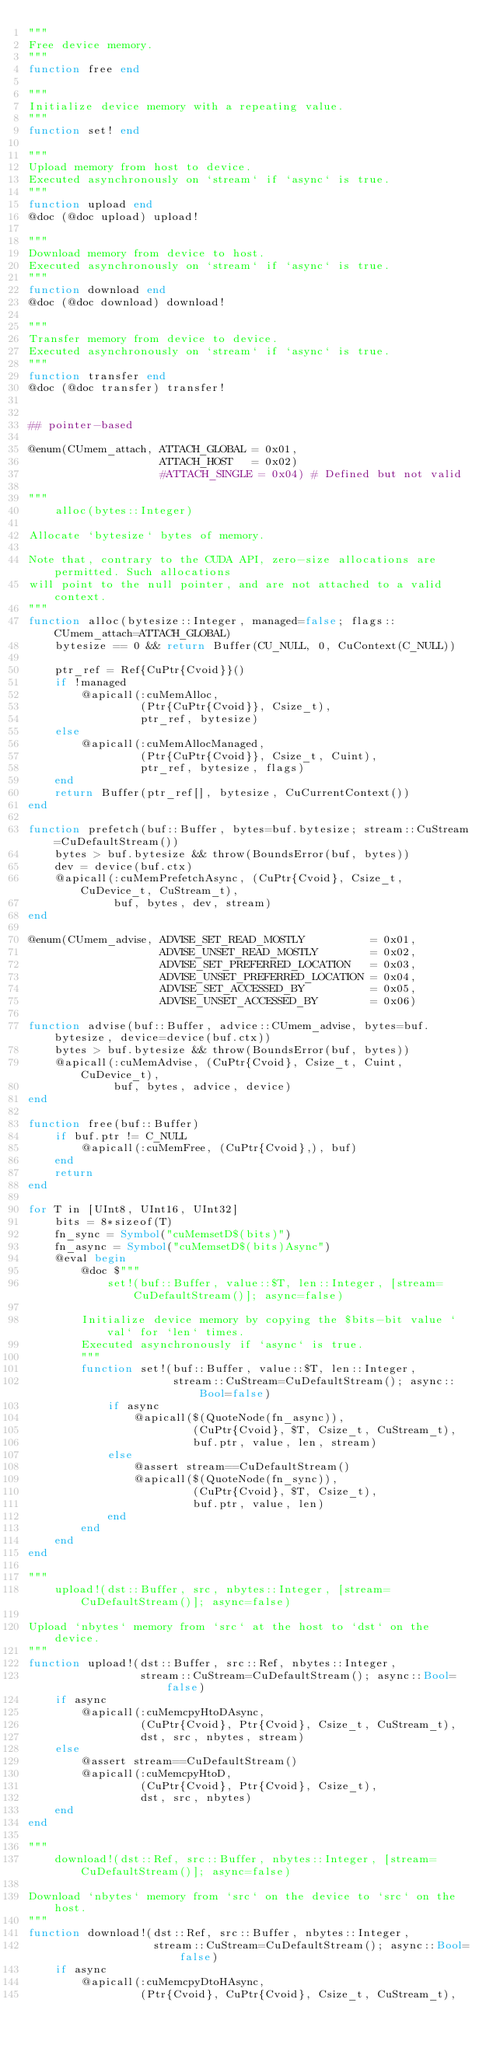<code> <loc_0><loc_0><loc_500><loc_500><_Julia_>"""
Free device memory.
"""
function free end

"""
Initialize device memory with a repeating value.
"""
function set! end

"""
Upload memory from host to device.
Executed asynchronously on `stream` if `async` is true.
"""
function upload end
@doc (@doc upload) upload!

"""
Download memory from device to host.
Executed asynchronously on `stream` if `async` is true.
"""
function download end
@doc (@doc download) download!

"""
Transfer memory from device to device.
Executed asynchronously on `stream` if `async` is true.
"""
function transfer end
@doc (@doc transfer) transfer!


## pointer-based

@enum(CUmem_attach, ATTACH_GLOBAL = 0x01,
                    ATTACH_HOST   = 0x02)
                    #ATTACH_SINGLE = 0x04) # Defined but not valid

"""
    alloc(bytes::Integer)

Allocate `bytesize` bytes of memory.

Note that, contrary to the CUDA API, zero-size allocations are permitted. Such allocations
will point to the null pointer, and are not attached to a valid context.
"""
function alloc(bytesize::Integer, managed=false; flags::CUmem_attach=ATTACH_GLOBAL)
    bytesize == 0 && return Buffer(CU_NULL, 0, CuContext(C_NULL))

    ptr_ref = Ref{CuPtr{Cvoid}}()
    if !managed
        @apicall(:cuMemAlloc,
                 (Ptr{CuPtr{Cvoid}}, Csize_t),
                 ptr_ref, bytesize)
    else
        @apicall(:cuMemAllocManaged,
                 (Ptr{CuPtr{Cvoid}}, Csize_t, Cuint),
                 ptr_ref, bytesize, flags)
    end
    return Buffer(ptr_ref[], bytesize, CuCurrentContext())
end

function prefetch(buf::Buffer, bytes=buf.bytesize; stream::CuStream=CuDefaultStream())
    bytes > buf.bytesize && throw(BoundsError(buf, bytes))
    dev = device(buf.ctx)
    @apicall(:cuMemPrefetchAsync, (CuPtr{Cvoid}, Csize_t, CuDevice_t, CuStream_t),
             buf, bytes, dev, stream)
end

@enum(CUmem_advise, ADVISE_SET_READ_MOSTLY          = 0x01,
                    ADVISE_UNSET_READ_MOSTLY        = 0x02,
                    ADVISE_SET_PREFERRED_LOCATION   = 0x03,
                    ADVISE_UNSET_PREFERRED_LOCATION = 0x04,
                    ADVISE_SET_ACCESSED_BY          = 0x05,
                    ADVISE_UNSET_ACCESSED_BY        = 0x06)

function advise(buf::Buffer, advice::CUmem_advise, bytes=buf.bytesize, device=device(buf.ctx))
    bytes > buf.bytesize && throw(BoundsError(buf, bytes))
    @apicall(:cuMemAdvise, (CuPtr{Cvoid}, Csize_t, Cuint, CuDevice_t),
             buf, bytes, advice, device)
end

function free(buf::Buffer)
    if buf.ptr != C_NULL
        @apicall(:cuMemFree, (CuPtr{Cvoid},), buf)
    end
    return
end

for T in [UInt8, UInt16, UInt32]
    bits = 8*sizeof(T)
    fn_sync = Symbol("cuMemsetD$(bits)")
    fn_async = Symbol("cuMemsetD$(bits)Async")
    @eval begin
        @doc $"""
            set!(buf::Buffer, value::$T, len::Integer, [stream=CuDefaultStream()]; async=false)

        Initialize device memory by copying the $bits-bit value `val` for `len` times.
        Executed asynchronously if `async` is true.
        """
        function set!(buf::Buffer, value::$T, len::Integer,
                      stream::CuStream=CuDefaultStream(); async::Bool=false)
            if async
                @apicall($(QuoteNode(fn_async)),
                         (CuPtr{Cvoid}, $T, Csize_t, CuStream_t),
                         buf.ptr, value, len, stream)
            else
                @assert stream==CuDefaultStream()
                @apicall($(QuoteNode(fn_sync)),
                         (CuPtr{Cvoid}, $T, Csize_t),
                         buf.ptr, value, len)
            end
        end
    end
end

"""
    upload!(dst::Buffer, src, nbytes::Integer, [stream=CuDefaultStream()]; async=false)

Upload `nbytes` memory from `src` at the host to `dst` on the device.
"""
function upload!(dst::Buffer, src::Ref, nbytes::Integer,
                 stream::CuStream=CuDefaultStream(); async::Bool=false)
    if async
        @apicall(:cuMemcpyHtoDAsync,
                 (CuPtr{Cvoid}, Ptr{Cvoid}, Csize_t, CuStream_t),
                 dst, src, nbytes, stream)
    else
        @assert stream==CuDefaultStream()
        @apicall(:cuMemcpyHtoD,
                 (CuPtr{Cvoid}, Ptr{Cvoid}, Csize_t),
                 dst, src, nbytes)
    end
end

"""
    download!(dst::Ref, src::Buffer, nbytes::Integer, [stream=CuDefaultStream()]; async=false)

Download `nbytes` memory from `src` on the device to `src` on the host.
"""
function download!(dst::Ref, src::Buffer, nbytes::Integer,
                   stream::CuStream=CuDefaultStream(); async::Bool=false)
    if async
        @apicall(:cuMemcpyDtoHAsync,
                 (Ptr{Cvoid}, CuPtr{Cvoid}, Csize_t, CuStream_t),</code> 